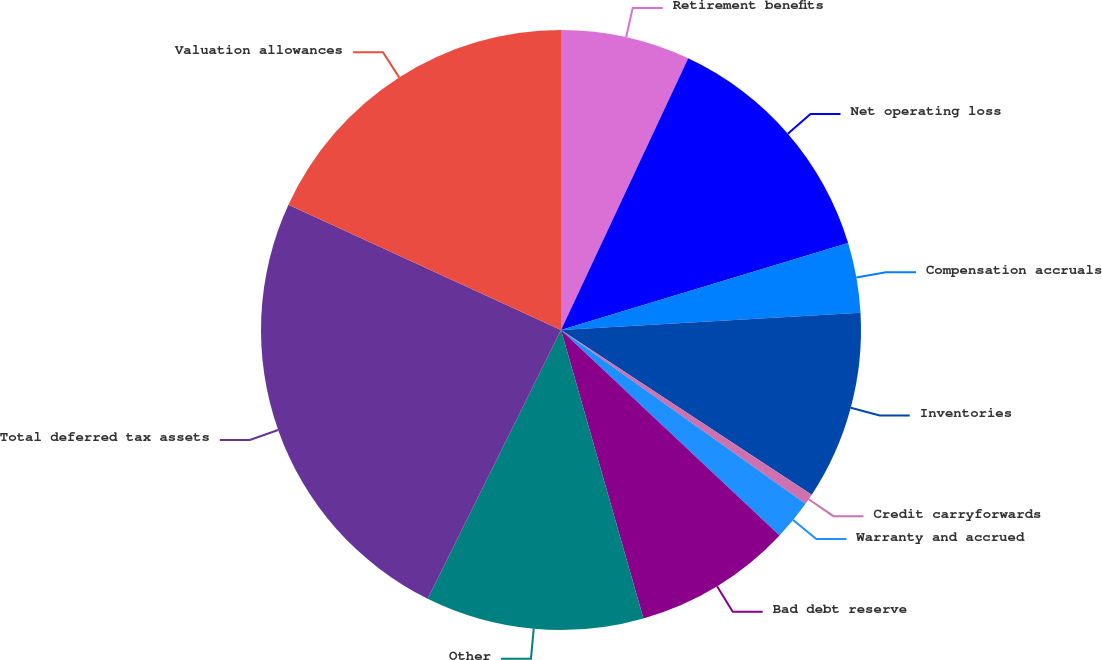<chart> <loc_0><loc_0><loc_500><loc_500><pie_chart><fcel>Retirement benefits<fcel>Net operating loss<fcel>Compensation accruals<fcel>Inventories<fcel>Credit carryforwards<fcel>Warranty and accrued<fcel>Bad debt reserve<fcel>Other<fcel>Total deferred tax assets<fcel>Valuation allowances<nl><fcel>6.97%<fcel>13.35%<fcel>3.77%<fcel>10.16%<fcel>0.58%<fcel>2.18%<fcel>8.56%<fcel>11.76%<fcel>24.53%<fcel>18.14%<nl></chart> 